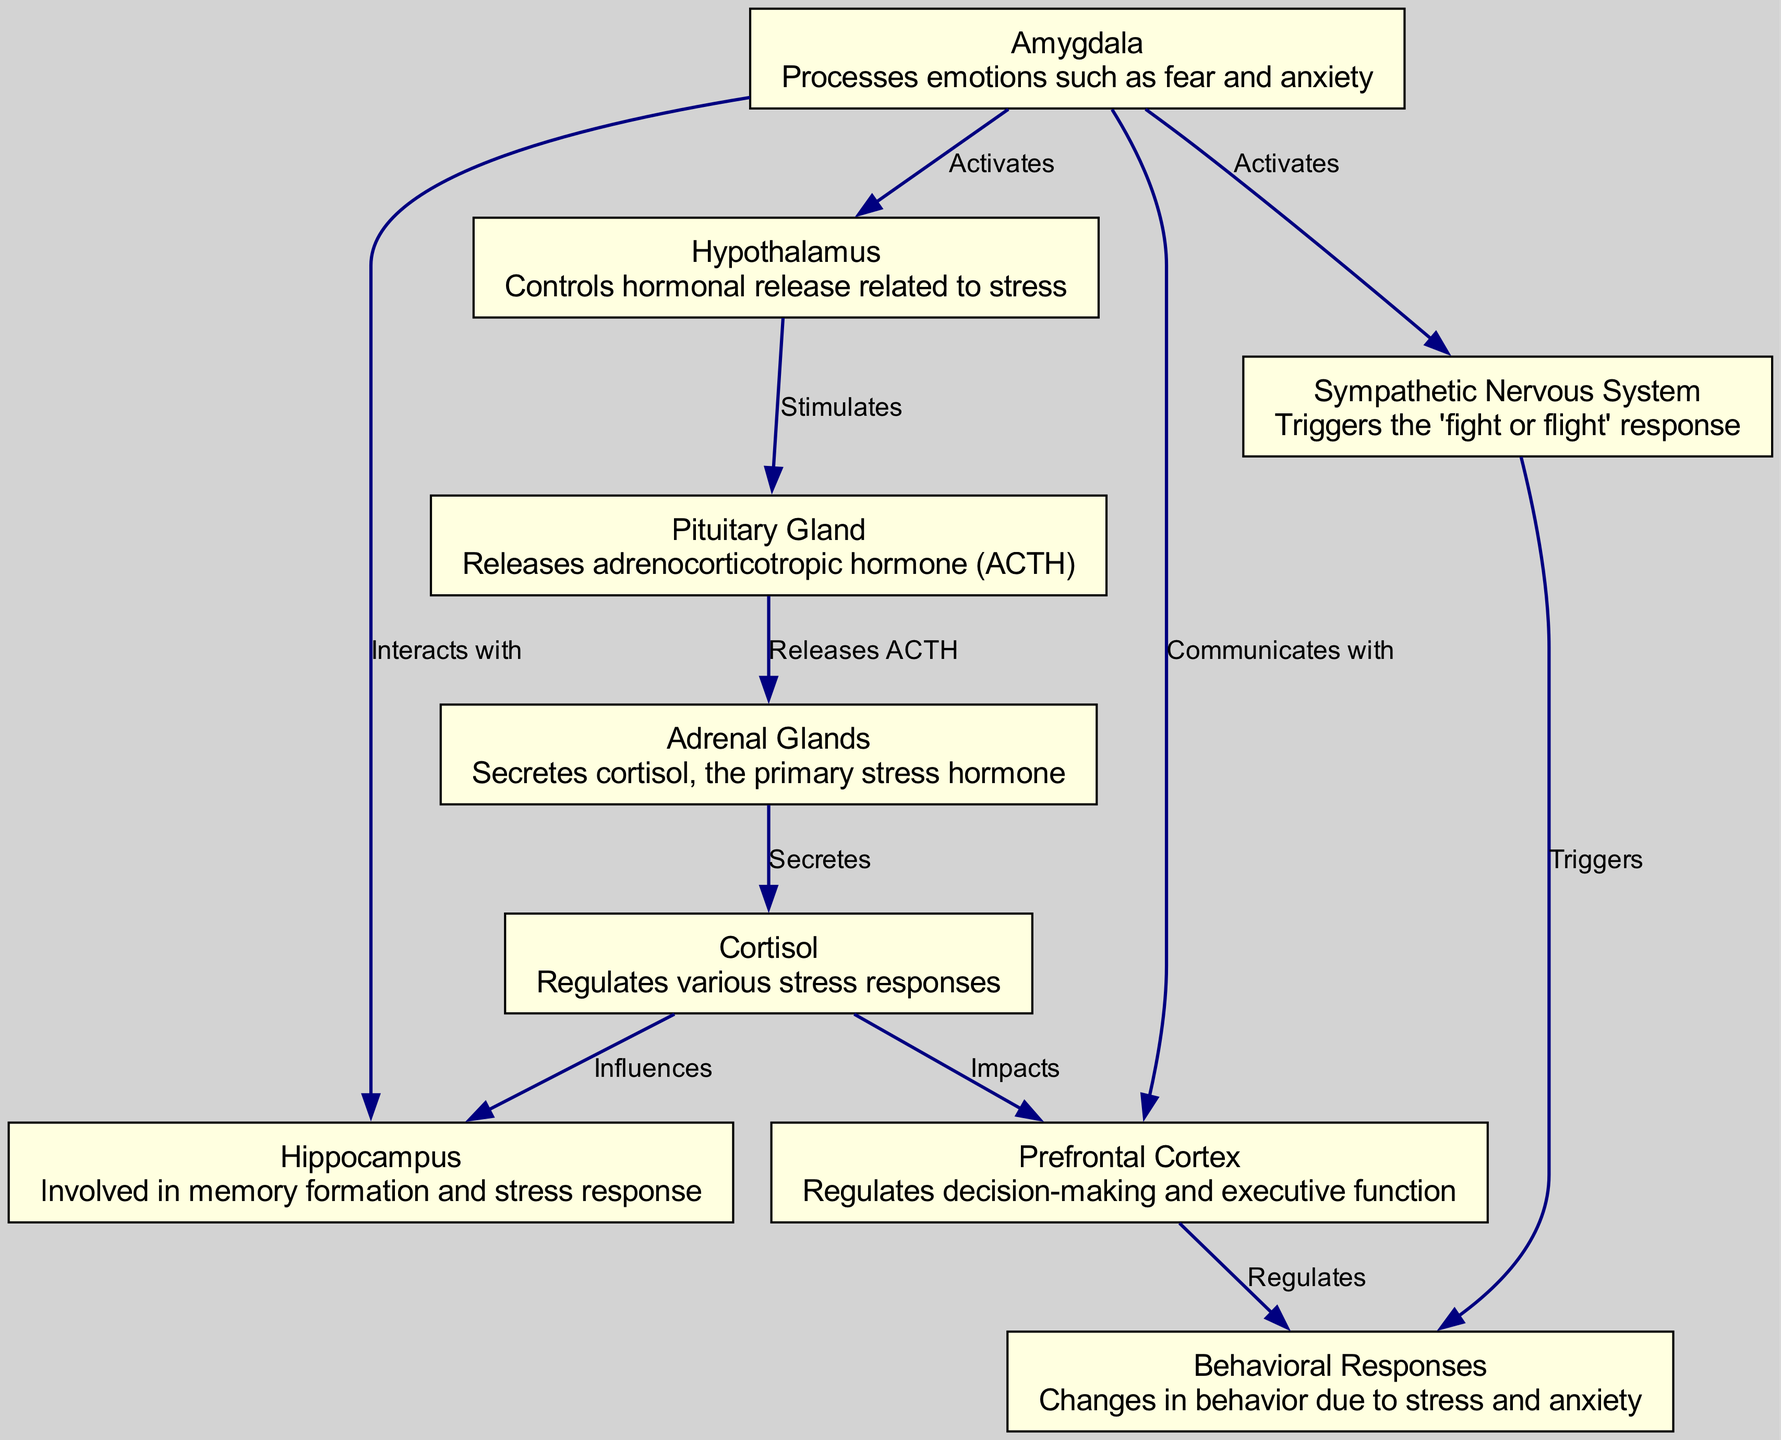What brain region processes fear and anxiety? The diagram shows that the amygdala is the node that processes emotions such as fear and anxiety. It is distinctly marked as the area responsible for these emotions.
Answer: Amygdala Which hormone is released by the pituitary gland? According to the diagram, the pituitary gland releases adrenocorticotropic hormone, depicted as an edge from the pituitary gland to the adrenal glands labeled "Releases ACTH."
Answer: ACTH How many brain regions are involved in stress pathways? The diagram lists seven distinct nodes that represent different regions and glands involved in the neural pathways related to stress and anxiety. Counting these nodes gives us the total.
Answer: 7 What does cortisol impact according to the diagram? The diagram shows direct arrows from cortisol to both the prefrontal cortex and the hippocampus, indicating that it impacts these brain regions. Therefore, the answer will include both regions mentioned in the connections.
Answer: Prefrontal Cortex, Hippocampus What triggers behavioral responses according to the sympathetic nervous system? The diagram indicates that the sympathetic nervous system triggers behavioral responses, as it shows a direct arrow from the sympathetic nervous system to the behavioral responses node labeled "Triggers."
Answer: Triggers Which brain region regulates decision-making? The prefrontal cortex is identified as the area that regulates decision-making and executive function, as stated in its description in the diagram.
Answer: Prefrontal Cortex How does stress influence the hippocampus? Stress affects the hippocampus through the influence of cortisol, as shown in the diagram where cortisol is linked to the hippocampus with the label "Influences." This means the relationship of cortisol with the hippocampus provides the answer.
Answer: Influences What activates the hypothalamus in response to stress? The amygdala activates the hypothalamus, and this is depicted in the diagram with an edge labeled "Activates" from the amygdala to the hypothalamus.
Answer: Activates What overall response does the sympathetic nervous system contribute to? The sympathetic nervous system triggers behavioral responses, indicated by the direct connection to the behavioral responses node labeled "Triggers" in the diagram.
Answer: Behavioral Responses 